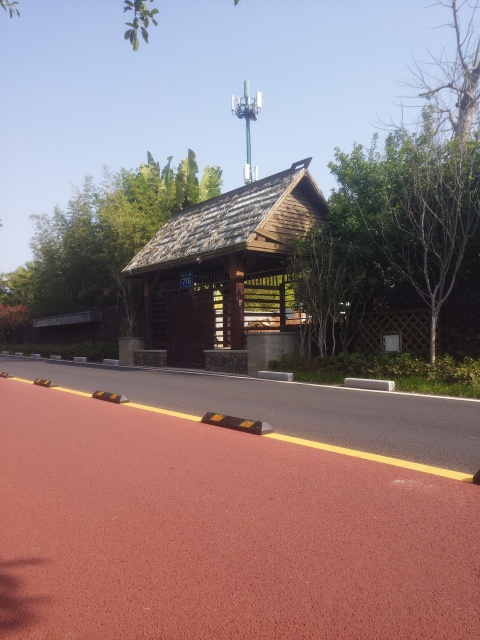What is the structure depicted in the image used for? The structure appears to be a small pavilion or rest area, possibly used by pedestrians or cyclists as a place to sit and rest, perhaps enjoying the view or taking shelter from the sun. 